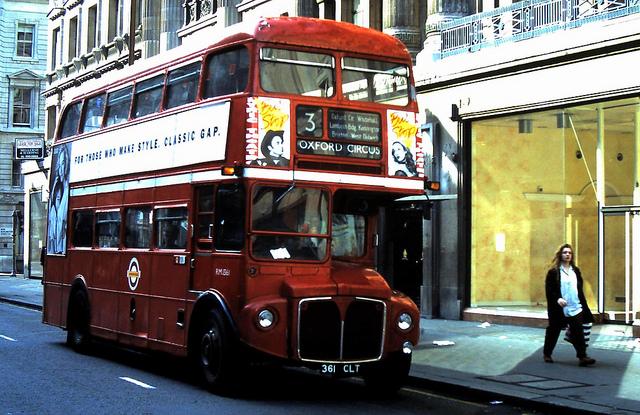Is the bus double decker?
Concise answer only. Yes. Where is the man?
Be succinct. Sidewalk. Is the building in the background empty?
Keep it brief. Yes. 